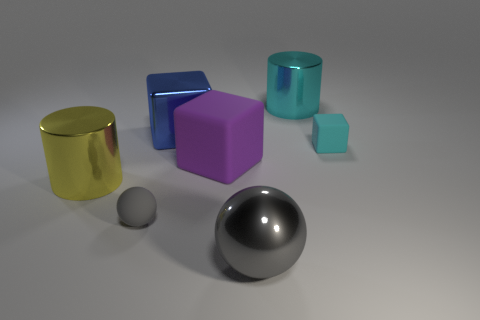What is the size of the gray object that is the same material as the purple thing?
Ensure brevity in your answer.  Small. What is the shape of the object that is both on the right side of the big gray metallic thing and on the left side of the small cyan object?
Make the answer very short. Cylinder. How big is the metallic thing that is to the right of the big blue metal object and behind the gray metal thing?
Give a very brief answer. Large. What is the material of the big object that is the same color as the tiny block?
Give a very brief answer. Metal. There is a large cyan object; is its shape the same as the small matte object in front of the tiny matte block?
Keep it short and to the point. No. Are there any cubes that have the same material as the yellow cylinder?
Offer a very short reply. Yes. There is a big yellow thing on the left side of the gray ball that is behind the large gray object; are there any big purple matte blocks on the left side of it?
Offer a very short reply. No. What number of other things are there of the same shape as the big purple rubber object?
Offer a terse response. 2. The rubber object right of the cylinder behind the cylinder in front of the cyan matte cube is what color?
Give a very brief answer. Cyan. What number of blue metallic cubes are there?
Ensure brevity in your answer.  1. 